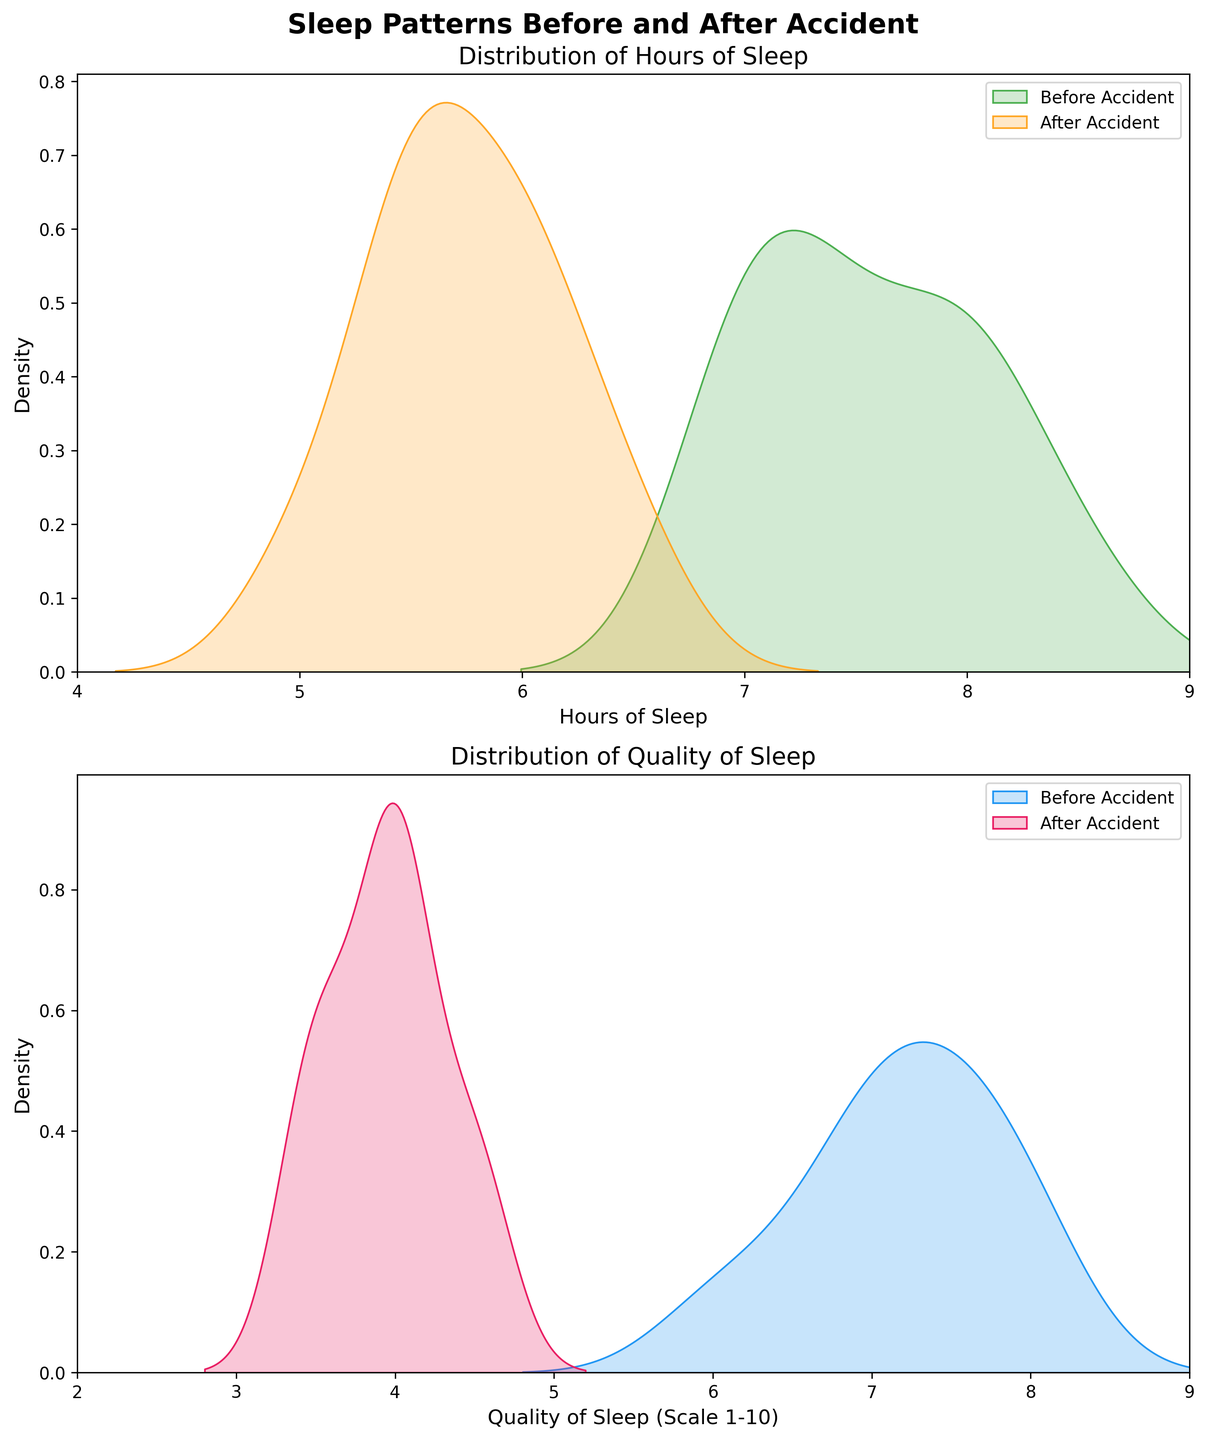what are the two conditions compared in the figure? The figure's titles and legends specify the two conditions compared in both subplots: "Before Accident" and "After Accident." These labels indicate the sleep patterns observed before and after the head injury caused by the car accident.
Answer: Before Accident, After Accident Which subplot shows the distribution of hours of sleep? The titles of the subplots guide us here. The first subplot (labeled "Distribution of Hours of Sleep") is focused on illustrating how the hours of sleep vary under different conditions.
Answer: The first subplot What colors represent the periods "Before Accident" and "After Accident" in the Distribution of Hours of Sleep graph? The legend in the first subplot explains that the "Before Accident" period is shown in green, while the "After Accident" period is represented in orange.
Answer: Green for Before Accident, Orange for After Accident What's the range of the x-axis in the Distribution of Hours of Sleep graph? The x-axis in the first subplot ranges from 4 to 9, as indicated by the axis labels. This range includes most common values of hours of sleep plotted in the graph.
Answer: 4 to 9 Between the two periods, which one has a wider range of distribution in Quality of Sleep scores? By examining the second subplot and comparing the spans of the density curves, it is evident that the "Before Accident" (blue) curve covers a larger range approximately from 6 to 9, whereas "After Accident" (pink) is concentrated from about 3 to 5.
Answer: Before Accident Which condition shows higher density for Hours of Sleep around 6 hours? In the first subplot, the orange "After Accident" curve has higher density around the 6-hour mark compared to the green "Before Accident" curve. This indicates more concentration of values there for the "After Accident" condition.
Answer: After Accident What is the most notable difference in Quality of Sleep distributions between the two periods? Observing the second subplot, the "Before Accident" condition (blue) tends to have higher quality scores clustering around 7 to 8, while the "After Accident" condition (pink) clusters around much lower quality scores, typically around 3 to 4.
Answer: Quality of Sleep is higher before the accident Are there any overlaps in the distributions of Hours of Sleep for the two conditions? In the first subplot, both the green (Before Accident) and orange (After Accident) curves overlap between approximately 5.5 and 8 hours of sleep, indicating that for this range, individuals from both periods had some hours of sleep within these values.
Answer: Yes, between 5.5 and 8 hours Does any period have extremum (highest peak) in either subplot? If so, which period, and in which graph? The first subplot shows the "Before Accident" (green) peak around 8 hours of sleep which is relatively higher than other parts of its curve. Similarly, the second subplot shows the highest peak for "Before Accident" (blue) around 7 to 8 quality scores, indicating it has the most concentrated data there.
Answer: Before Accident, around 8 hours of sleep in the first subplot, and 7 to 8 hours Quality of Sleep in the second subplot What can you infer about the impact of the accident on sleep quality from the plots? From the second subplot, it's clear that quality of sleep declined significantly after the accident. The pink curve (After Accident) is skewed towards lower values (around 3-4), while the blue curve (Before Accident) is concentrated around higher values (around 7-8), indicating a notable decrease in quality post-accident.
Answer: Quality declined significantly after the accident 